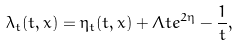<formula> <loc_0><loc_0><loc_500><loc_500>\lambda _ { t } ( t , x ) = \eta _ { t } ( t , x ) + \Lambda t e ^ { 2 \eta } - \frac { 1 } { t } ,</formula> 